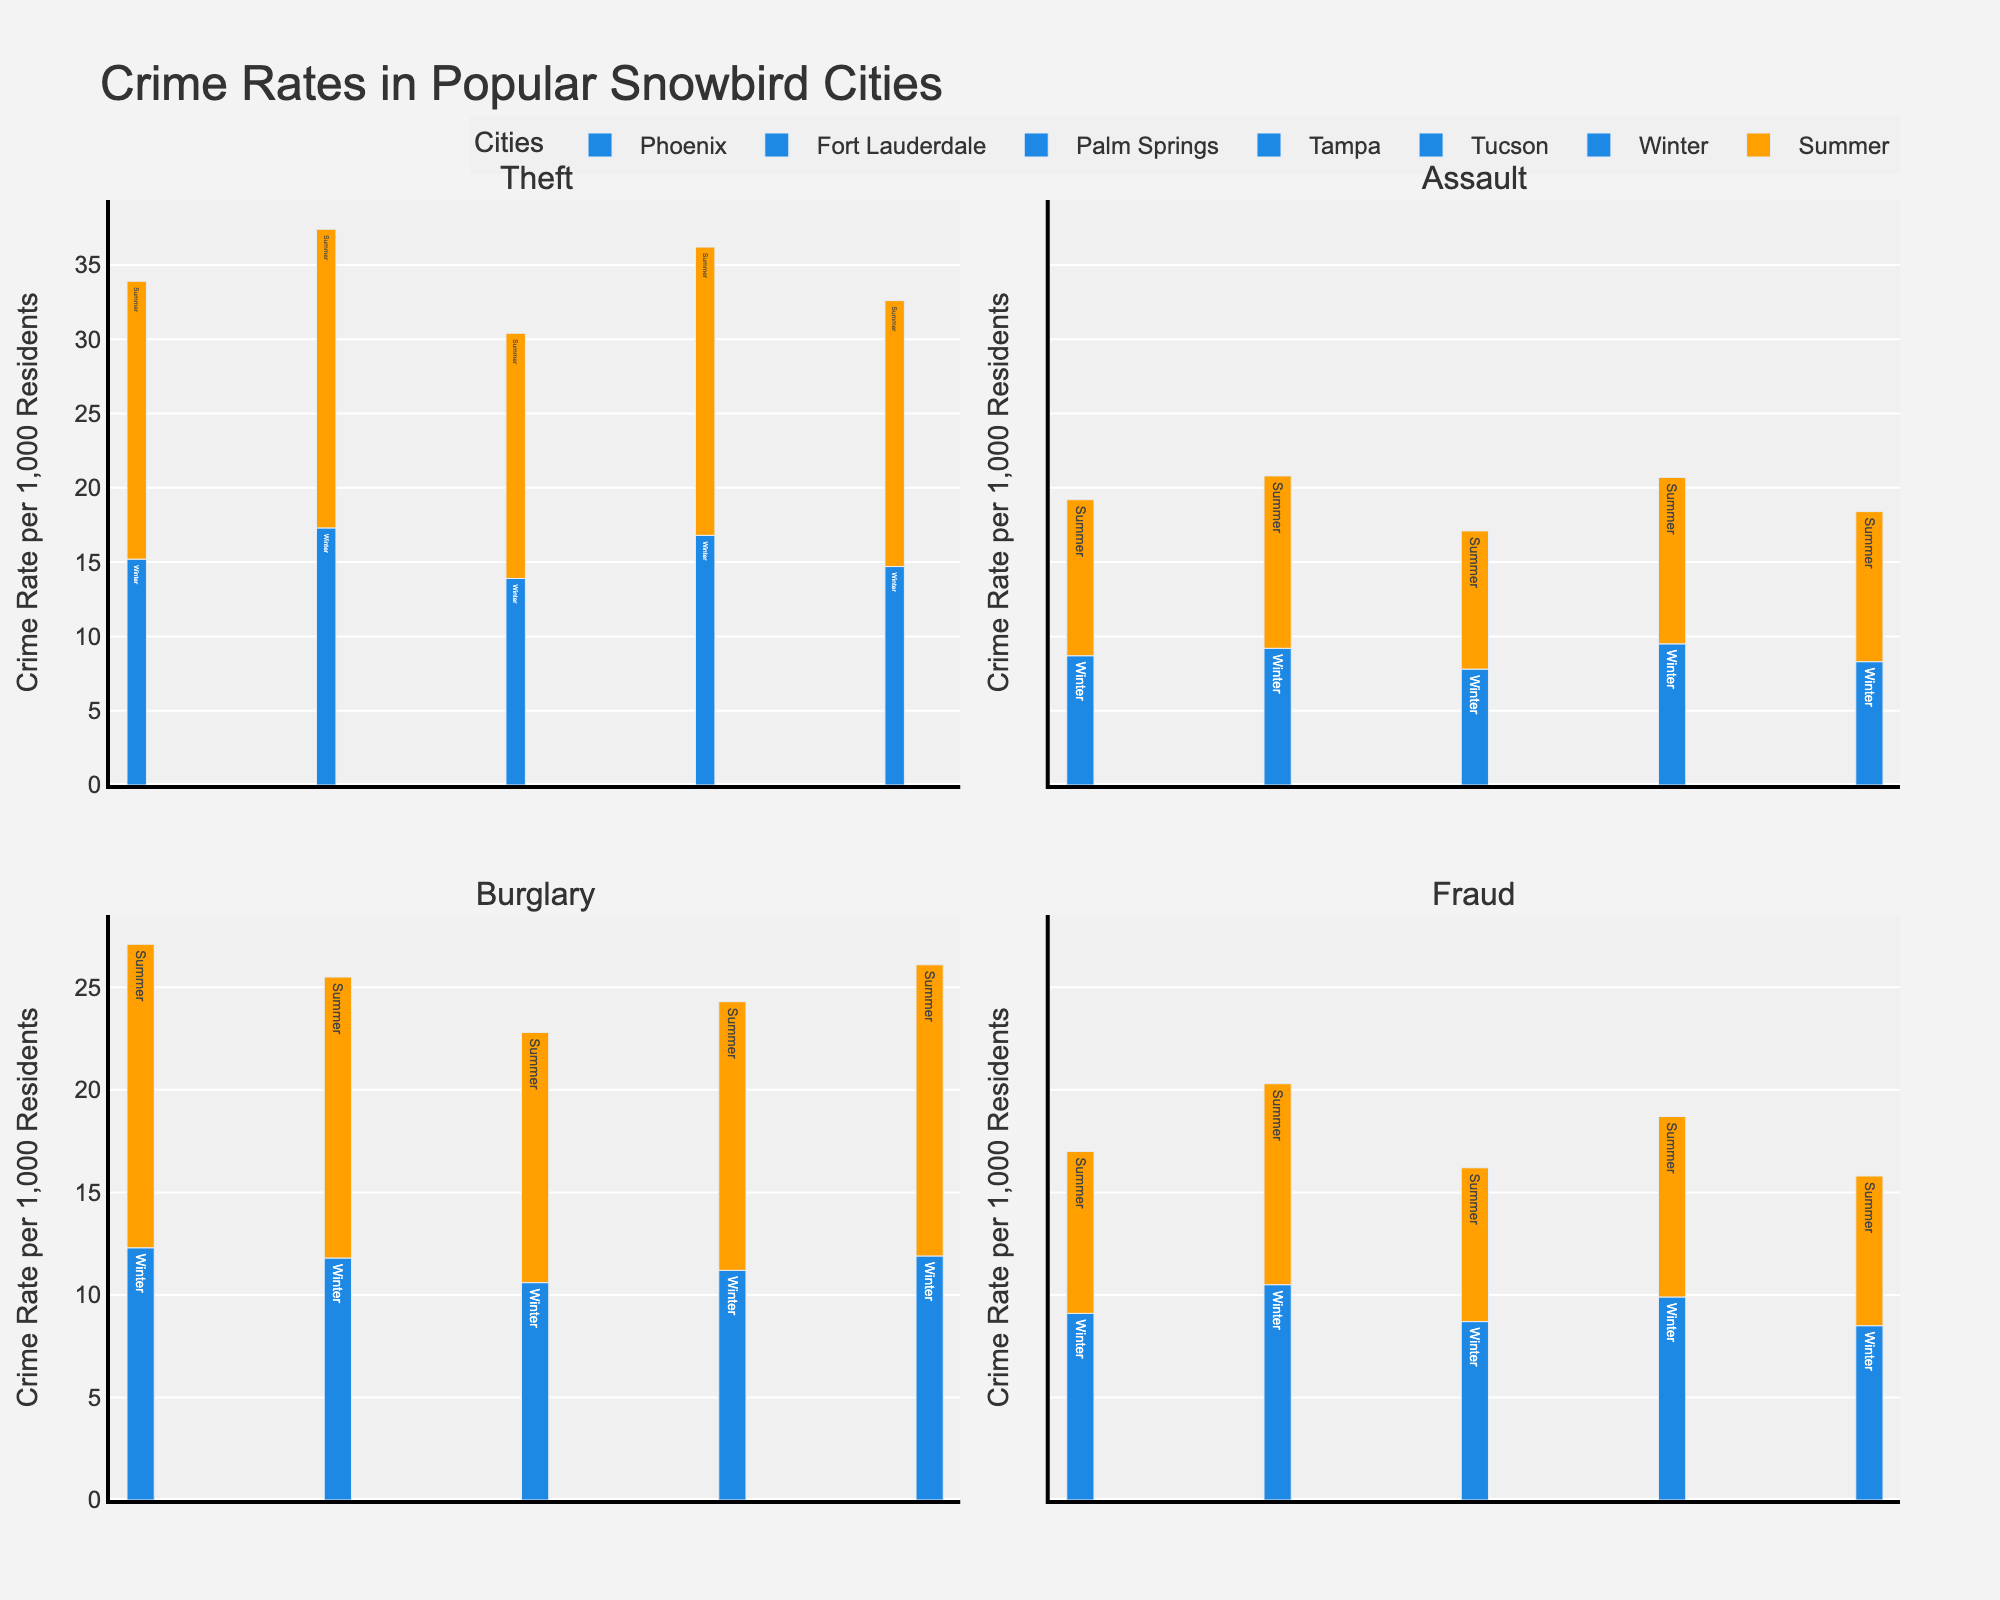What is the title of the figure? The title is usually placed at the top of the figure and describes what the figure represents. The title here is located at the top and reads "Crime Rates in Popular Snowbird Cities".
Answer: Crime Rates in Popular Snowbird Cities How many types of crime offenses are displayed in the figure? Each subplot represents a different type of crime offense. By counting the subplots or looking at the subplot titles, we can see there are four types: Theft, Assault, Burglary, and Fraud.
Answer: Four Which city has the highest theft rate in the summer? To identify this, look at the Theft subplot and locate the highest bar for Summer (orange color). The bar that represents Phoenix is the highest.
Answer: Phoenix Which city has the lowest burglary rate in winter? Look at the Burglary subplot and focus on the winter bars (blue color). The lowest bar belongs to Palm Springs.
Answer: Palm Springs Compare the fraud rates in winter between Phoenix and Tampa. Which city has a higher rate and by how much? Look at the Fraud subplot and compare the winter bars for Phoenix and Tampa. Phoenix has a rate of 9.1 and Tampa has 9.9. Subtract 9.1 from 9.9 to find the difference.
Answer: Tampa by 0.8 What are the average theft rates for Phoenix in winter and summer? To find the average, add the winter and summer theft rates for Phoenix and divide by 2. Phoenix has 15.2 in winter and 18.7 in summer, so (15.2 + 18.7) / 2.
Answer: 16.95 Which offense type has the least seasonal variation (difference between winter and summer) in Tampa? Calculate the differences between winter and summer rates for each offense type in Tampa. Theft: 19.4 - 16.8 = 2.6, Assault: 11.2 - 9.5 = 1.7, Burglary: 13.1 - 11.2 = 1.9, Fraud: 8.8 - 9.9 = -1.1. The smallest absolute value is for Assault.
Answer: Assault During which season does Fort Lauderdale have a higher overall crime rate, and what is the average rate for that season? Sum the crime rates for Fort Lauderdale in each season first. Winter: 17.3 + 9.2 + 11.8 + 10.5 = 48.8. Summer: 20.1 + 11.6 + 13.7 + 9.8 = 55.2. Average for Summer: 55.2 / 4 = 13.8. Winter: 48.8 / 4 = 12.2.
Answer: Summer, 13.8 Which city and which offense have the closest crime rates between winter and summer? Calculate the difference between winter and summer rates for each offense in all cities. The smallest difference is for Assault in Tucson, with 10.1 - 8.3 = 1.8.
Answer: Tucson, Assault Compare winter burglary rates between Palm Springs and Tucson. Which city has a lower rate? Look at the Burglary subplot and compare the winter bars for Palm Springs and Tucson. Palm Springs has a rate of 10.6, and Tucson has 11.9. Palm Springs is lower.
Answer: Palm Springs 